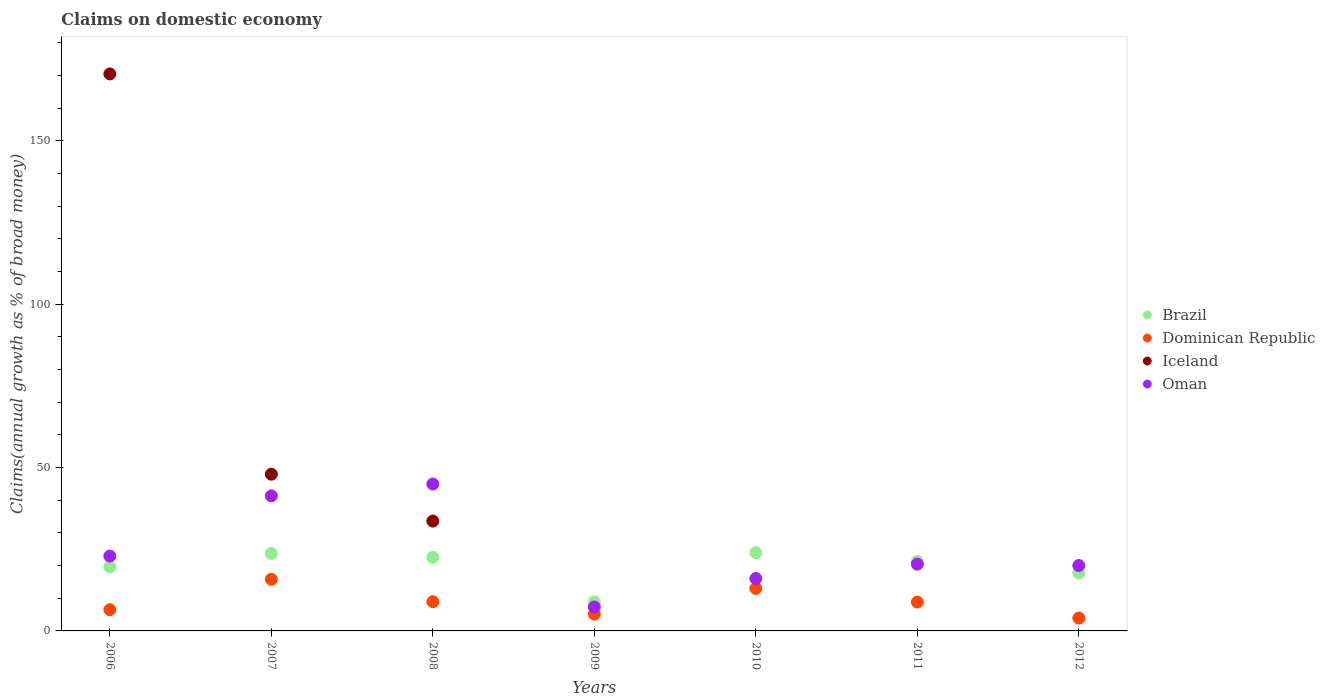What is the percentage of broad money claimed on domestic economy in Brazil in 2006?
Give a very brief answer. 19.61. Across all years, what is the maximum percentage of broad money claimed on domestic economy in Oman?
Your answer should be compact. 44.98. Across all years, what is the minimum percentage of broad money claimed on domestic economy in Oman?
Your answer should be very brief. 7.33. In which year was the percentage of broad money claimed on domestic economy in Dominican Republic maximum?
Offer a very short reply. 2007. What is the total percentage of broad money claimed on domestic economy in Brazil in the graph?
Provide a short and direct response. 137.71. What is the difference between the percentage of broad money claimed on domestic economy in Brazil in 2006 and that in 2008?
Your response must be concise. -2.91. What is the difference between the percentage of broad money claimed on domestic economy in Brazil in 2011 and the percentage of broad money claimed on domestic economy in Iceland in 2009?
Your answer should be very brief. 21.28. What is the average percentage of broad money claimed on domestic economy in Brazil per year?
Keep it short and to the point. 19.67. In the year 2008, what is the difference between the percentage of broad money claimed on domestic economy in Oman and percentage of broad money claimed on domestic economy in Iceland?
Keep it short and to the point. 11.34. What is the ratio of the percentage of broad money claimed on domestic economy in Oman in 2006 to that in 2011?
Your response must be concise. 1.12. Is the percentage of broad money claimed on domestic economy in Oman in 2007 less than that in 2010?
Your answer should be very brief. No. What is the difference between the highest and the second highest percentage of broad money claimed on domestic economy in Iceland?
Your response must be concise. 122.54. What is the difference between the highest and the lowest percentage of broad money claimed on domestic economy in Dominican Republic?
Provide a succinct answer. 11.85. Is the percentage of broad money claimed on domestic economy in Iceland strictly greater than the percentage of broad money claimed on domestic economy in Dominican Republic over the years?
Keep it short and to the point. No. How many dotlines are there?
Offer a terse response. 4. Are the values on the major ticks of Y-axis written in scientific E-notation?
Make the answer very short. No. Does the graph contain any zero values?
Your response must be concise. Yes. Does the graph contain grids?
Ensure brevity in your answer.  No. Where does the legend appear in the graph?
Your answer should be compact. Center right. How many legend labels are there?
Keep it short and to the point. 4. How are the legend labels stacked?
Offer a terse response. Vertical. What is the title of the graph?
Ensure brevity in your answer.  Claims on domestic economy. What is the label or title of the Y-axis?
Your response must be concise. Claims(annual growth as % of broad money). What is the Claims(annual growth as % of broad money) of Brazil in 2006?
Your answer should be compact. 19.61. What is the Claims(annual growth as % of broad money) in Dominican Republic in 2006?
Give a very brief answer. 6.51. What is the Claims(annual growth as % of broad money) of Iceland in 2006?
Offer a very short reply. 170.52. What is the Claims(annual growth as % of broad money) in Oman in 2006?
Ensure brevity in your answer.  22.92. What is the Claims(annual growth as % of broad money) in Brazil in 2007?
Keep it short and to the point. 23.73. What is the Claims(annual growth as % of broad money) in Dominican Republic in 2007?
Offer a terse response. 15.79. What is the Claims(annual growth as % of broad money) in Iceland in 2007?
Your answer should be very brief. 47.98. What is the Claims(annual growth as % of broad money) of Oman in 2007?
Offer a very short reply. 41.35. What is the Claims(annual growth as % of broad money) in Brazil in 2008?
Provide a short and direct response. 22.52. What is the Claims(annual growth as % of broad money) in Dominican Republic in 2008?
Your answer should be very brief. 8.95. What is the Claims(annual growth as % of broad money) in Iceland in 2008?
Ensure brevity in your answer.  33.63. What is the Claims(annual growth as % of broad money) in Oman in 2008?
Provide a short and direct response. 44.98. What is the Claims(annual growth as % of broad money) in Brazil in 2009?
Offer a terse response. 8.89. What is the Claims(annual growth as % of broad money) of Dominican Republic in 2009?
Your answer should be very brief. 5.15. What is the Claims(annual growth as % of broad money) of Iceland in 2009?
Provide a succinct answer. 0. What is the Claims(annual growth as % of broad money) of Oman in 2009?
Offer a terse response. 7.33. What is the Claims(annual growth as % of broad money) in Brazil in 2010?
Your answer should be compact. 23.96. What is the Claims(annual growth as % of broad money) in Dominican Republic in 2010?
Offer a very short reply. 13.01. What is the Claims(annual growth as % of broad money) of Iceland in 2010?
Offer a very short reply. 0. What is the Claims(annual growth as % of broad money) of Oman in 2010?
Ensure brevity in your answer.  16.05. What is the Claims(annual growth as % of broad money) in Brazil in 2011?
Provide a succinct answer. 21.28. What is the Claims(annual growth as % of broad money) of Dominican Republic in 2011?
Your answer should be very brief. 8.83. What is the Claims(annual growth as % of broad money) in Oman in 2011?
Give a very brief answer. 20.43. What is the Claims(annual growth as % of broad money) in Brazil in 2012?
Provide a succinct answer. 17.72. What is the Claims(annual growth as % of broad money) in Dominican Republic in 2012?
Offer a very short reply. 3.94. What is the Claims(annual growth as % of broad money) of Oman in 2012?
Your answer should be compact. 20.01. Across all years, what is the maximum Claims(annual growth as % of broad money) in Brazil?
Ensure brevity in your answer.  23.96. Across all years, what is the maximum Claims(annual growth as % of broad money) in Dominican Republic?
Give a very brief answer. 15.79. Across all years, what is the maximum Claims(annual growth as % of broad money) in Iceland?
Make the answer very short. 170.52. Across all years, what is the maximum Claims(annual growth as % of broad money) in Oman?
Your answer should be very brief. 44.98. Across all years, what is the minimum Claims(annual growth as % of broad money) in Brazil?
Offer a terse response. 8.89. Across all years, what is the minimum Claims(annual growth as % of broad money) in Dominican Republic?
Provide a succinct answer. 3.94. Across all years, what is the minimum Claims(annual growth as % of broad money) in Oman?
Provide a short and direct response. 7.33. What is the total Claims(annual growth as % of broad money) of Brazil in the graph?
Keep it short and to the point. 137.71. What is the total Claims(annual growth as % of broad money) in Dominican Republic in the graph?
Offer a very short reply. 62.18. What is the total Claims(annual growth as % of broad money) in Iceland in the graph?
Offer a very short reply. 252.13. What is the total Claims(annual growth as % of broad money) in Oman in the graph?
Ensure brevity in your answer.  173.06. What is the difference between the Claims(annual growth as % of broad money) in Brazil in 2006 and that in 2007?
Provide a succinct answer. -4.13. What is the difference between the Claims(annual growth as % of broad money) in Dominican Republic in 2006 and that in 2007?
Offer a very short reply. -9.28. What is the difference between the Claims(annual growth as % of broad money) in Iceland in 2006 and that in 2007?
Offer a very short reply. 122.54. What is the difference between the Claims(annual growth as % of broad money) in Oman in 2006 and that in 2007?
Your answer should be very brief. -18.43. What is the difference between the Claims(annual growth as % of broad money) of Brazil in 2006 and that in 2008?
Ensure brevity in your answer.  -2.91. What is the difference between the Claims(annual growth as % of broad money) in Dominican Republic in 2006 and that in 2008?
Keep it short and to the point. -2.44. What is the difference between the Claims(annual growth as % of broad money) in Iceland in 2006 and that in 2008?
Your answer should be very brief. 136.89. What is the difference between the Claims(annual growth as % of broad money) of Oman in 2006 and that in 2008?
Your answer should be compact. -22.06. What is the difference between the Claims(annual growth as % of broad money) of Brazil in 2006 and that in 2009?
Your answer should be very brief. 10.72. What is the difference between the Claims(annual growth as % of broad money) of Dominican Republic in 2006 and that in 2009?
Offer a very short reply. 1.36. What is the difference between the Claims(annual growth as % of broad money) of Oman in 2006 and that in 2009?
Offer a terse response. 15.59. What is the difference between the Claims(annual growth as % of broad money) in Brazil in 2006 and that in 2010?
Your answer should be very brief. -4.35. What is the difference between the Claims(annual growth as % of broad money) in Dominican Republic in 2006 and that in 2010?
Provide a short and direct response. -6.5. What is the difference between the Claims(annual growth as % of broad money) in Oman in 2006 and that in 2010?
Provide a short and direct response. 6.87. What is the difference between the Claims(annual growth as % of broad money) in Brazil in 2006 and that in 2011?
Your answer should be compact. -1.68. What is the difference between the Claims(annual growth as % of broad money) of Dominican Republic in 2006 and that in 2011?
Provide a succinct answer. -2.31. What is the difference between the Claims(annual growth as % of broad money) of Oman in 2006 and that in 2011?
Ensure brevity in your answer.  2.49. What is the difference between the Claims(annual growth as % of broad money) of Brazil in 2006 and that in 2012?
Provide a succinct answer. 1.89. What is the difference between the Claims(annual growth as % of broad money) in Dominican Republic in 2006 and that in 2012?
Make the answer very short. 2.57. What is the difference between the Claims(annual growth as % of broad money) in Oman in 2006 and that in 2012?
Keep it short and to the point. 2.9. What is the difference between the Claims(annual growth as % of broad money) of Brazil in 2007 and that in 2008?
Ensure brevity in your answer.  1.22. What is the difference between the Claims(annual growth as % of broad money) in Dominican Republic in 2007 and that in 2008?
Ensure brevity in your answer.  6.84. What is the difference between the Claims(annual growth as % of broad money) in Iceland in 2007 and that in 2008?
Provide a succinct answer. 14.35. What is the difference between the Claims(annual growth as % of broad money) of Oman in 2007 and that in 2008?
Keep it short and to the point. -3.63. What is the difference between the Claims(annual growth as % of broad money) of Brazil in 2007 and that in 2009?
Offer a very short reply. 14.85. What is the difference between the Claims(annual growth as % of broad money) of Dominican Republic in 2007 and that in 2009?
Provide a short and direct response. 10.64. What is the difference between the Claims(annual growth as % of broad money) of Oman in 2007 and that in 2009?
Provide a succinct answer. 34.02. What is the difference between the Claims(annual growth as % of broad money) of Brazil in 2007 and that in 2010?
Offer a very short reply. -0.23. What is the difference between the Claims(annual growth as % of broad money) in Dominican Republic in 2007 and that in 2010?
Provide a succinct answer. 2.78. What is the difference between the Claims(annual growth as % of broad money) in Oman in 2007 and that in 2010?
Your response must be concise. 25.3. What is the difference between the Claims(annual growth as % of broad money) of Brazil in 2007 and that in 2011?
Keep it short and to the point. 2.45. What is the difference between the Claims(annual growth as % of broad money) in Dominican Republic in 2007 and that in 2011?
Keep it short and to the point. 6.97. What is the difference between the Claims(annual growth as % of broad money) of Oman in 2007 and that in 2011?
Your answer should be compact. 20.92. What is the difference between the Claims(annual growth as % of broad money) in Brazil in 2007 and that in 2012?
Provide a short and direct response. 6.02. What is the difference between the Claims(annual growth as % of broad money) of Dominican Republic in 2007 and that in 2012?
Give a very brief answer. 11.85. What is the difference between the Claims(annual growth as % of broad money) in Oman in 2007 and that in 2012?
Your response must be concise. 21.33. What is the difference between the Claims(annual growth as % of broad money) of Brazil in 2008 and that in 2009?
Your answer should be very brief. 13.63. What is the difference between the Claims(annual growth as % of broad money) of Dominican Republic in 2008 and that in 2009?
Make the answer very short. 3.79. What is the difference between the Claims(annual growth as % of broad money) in Oman in 2008 and that in 2009?
Keep it short and to the point. 37.65. What is the difference between the Claims(annual growth as % of broad money) in Brazil in 2008 and that in 2010?
Offer a terse response. -1.45. What is the difference between the Claims(annual growth as % of broad money) in Dominican Republic in 2008 and that in 2010?
Make the answer very short. -4.06. What is the difference between the Claims(annual growth as % of broad money) of Oman in 2008 and that in 2010?
Offer a very short reply. 28.92. What is the difference between the Claims(annual growth as % of broad money) in Brazil in 2008 and that in 2011?
Offer a very short reply. 1.23. What is the difference between the Claims(annual growth as % of broad money) in Dominican Republic in 2008 and that in 2011?
Offer a very short reply. 0.12. What is the difference between the Claims(annual growth as % of broad money) in Oman in 2008 and that in 2011?
Give a very brief answer. 24.55. What is the difference between the Claims(annual growth as % of broad money) in Brazil in 2008 and that in 2012?
Provide a succinct answer. 4.8. What is the difference between the Claims(annual growth as % of broad money) of Dominican Republic in 2008 and that in 2012?
Give a very brief answer. 5.01. What is the difference between the Claims(annual growth as % of broad money) of Oman in 2008 and that in 2012?
Provide a succinct answer. 24.96. What is the difference between the Claims(annual growth as % of broad money) in Brazil in 2009 and that in 2010?
Offer a very short reply. -15.07. What is the difference between the Claims(annual growth as % of broad money) in Dominican Republic in 2009 and that in 2010?
Offer a very short reply. -7.86. What is the difference between the Claims(annual growth as % of broad money) in Oman in 2009 and that in 2010?
Provide a short and direct response. -8.72. What is the difference between the Claims(annual growth as % of broad money) of Brazil in 2009 and that in 2011?
Make the answer very short. -12.4. What is the difference between the Claims(annual growth as % of broad money) in Dominican Republic in 2009 and that in 2011?
Provide a succinct answer. -3.67. What is the difference between the Claims(annual growth as % of broad money) of Oman in 2009 and that in 2011?
Keep it short and to the point. -13.1. What is the difference between the Claims(annual growth as % of broad money) of Brazil in 2009 and that in 2012?
Your answer should be compact. -8.83. What is the difference between the Claims(annual growth as % of broad money) in Dominican Republic in 2009 and that in 2012?
Make the answer very short. 1.22. What is the difference between the Claims(annual growth as % of broad money) in Oman in 2009 and that in 2012?
Your answer should be very brief. -12.69. What is the difference between the Claims(annual growth as % of broad money) of Brazil in 2010 and that in 2011?
Offer a very short reply. 2.68. What is the difference between the Claims(annual growth as % of broad money) in Dominican Republic in 2010 and that in 2011?
Your response must be concise. 4.19. What is the difference between the Claims(annual growth as % of broad money) in Oman in 2010 and that in 2011?
Make the answer very short. -4.38. What is the difference between the Claims(annual growth as % of broad money) in Brazil in 2010 and that in 2012?
Your response must be concise. 6.24. What is the difference between the Claims(annual growth as % of broad money) of Dominican Republic in 2010 and that in 2012?
Your answer should be compact. 9.07. What is the difference between the Claims(annual growth as % of broad money) of Oman in 2010 and that in 2012?
Offer a very short reply. -3.96. What is the difference between the Claims(annual growth as % of broad money) in Brazil in 2011 and that in 2012?
Offer a terse response. 3.56. What is the difference between the Claims(annual growth as % of broad money) of Dominican Republic in 2011 and that in 2012?
Offer a terse response. 4.89. What is the difference between the Claims(annual growth as % of broad money) of Oman in 2011 and that in 2012?
Your answer should be very brief. 0.41. What is the difference between the Claims(annual growth as % of broad money) in Brazil in 2006 and the Claims(annual growth as % of broad money) in Dominican Republic in 2007?
Provide a succinct answer. 3.82. What is the difference between the Claims(annual growth as % of broad money) in Brazil in 2006 and the Claims(annual growth as % of broad money) in Iceland in 2007?
Provide a short and direct response. -28.37. What is the difference between the Claims(annual growth as % of broad money) of Brazil in 2006 and the Claims(annual growth as % of broad money) of Oman in 2007?
Keep it short and to the point. -21.74. What is the difference between the Claims(annual growth as % of broad money) of Dominican Republic in 2006 and the Claims(annual growth as % of broad money) of Iceland in 2007?
Give a very brief answer. -41.47. What is the difference between the Claims(annual growth as % of broad money) in Dominican Republic in 2006 and the Claims(annual growth as % of broad money) in Oman in 2007?
Offer a terse response. -34.84. What is the difference between the Claims(annual growth as % of broad money) in Iceland in 2006 and the Claims(annual growth as % of broad money) in Oman in 2007?
Your answer should be compact. 129.17. What is the difference between the Claims(annual growth as % of broad money) in Brazil in 2006 and the Claims(annual growth as % of broad money) in Dominican Republic in 2008?
Keep it short and to the point. 10.66. What is the difference between the Claims(annual growth as % of broad money) of Brazil in 2006 and the Claims(annual growth as % of broad money) of Iceland in 2008?
Give a very brief answer. -14.02. What is the difference between the Claims(annual growth as % of broad money) of Brazil in 2006 and the Claims(annual growth as % of broad money) of Oman in 2008?
Your answer should be very brief. -25.37. What is the difference between the Claims(annual growth as % of broad money) in Dominican Republic in 2006 and the Claims(annual growth as % of broad money) in Iceland in 2008?
Provide a short and direct response. -27.12. What is the difference between the Claims(annual growth as % of broad money) of Dominican Republic in 2006 and the Claims(annual growth as % of broad money) of Oman in 2008?
Ensure brevity in your answer.  -38.47. What is the difference between the Claims(annual growth as % of broad money) of Iceland in 2006 and the Claims(annual growth as % of broad money) of Oman in 2008?
Give a very brief answer. 125.54. What is the difference between the Claims(annual growth as % of broad money) of Brazil in 2006 and the Claims(annual growth as % of broad money) of Dominican Republic in 2009?
Offer a very short reply. 14.45. What is the difference between the Claims(annual growth as % of broad money) of Brazil in 2006 and the Claims(annual growth as % of broad money) of Oman in 2009?
Make the answer very short. 12.28. What is the difference between the Claims(annual growth as % of broad money) of Dominican Republic in 2006 and the Claims(annual growth as % of broad money) of Oman in 2009?
Give a very brief answer. -0.82. What is the difference between the Claims(annual growth as % of broad money) of Iceland in 2006 and the Claims(annual growth as % of broad money) of Oman in 2009?
Keep it short and to the point. 163.19. What is the difference between the Claims(annual growth as % of broad money) in Brazil in 2006 and the Claims(annual growth as % of broad money) in Dominican Republic in 2010?
Your answer should be very brief. 6.6. What is the difference between the Claims(annual growth as % of broad money) of Brazil in 2006 and the Claims(annual growth as % of broad money) of Oman in 2010?
Keep it short and to the point. 3.56. What is the difference between the Claims(annual growth as % of broad money) in Dominican Republic in 2006 and the Claims(annual growth as % of broad money) in Oman in 2010?
Your answer should be compact. -9.54. What is the difference between the Claims(annual growth as % of broad money) in Iceland in 2006 and the Claims(annual growth as % of broad money) in Oman in 2010?
Provide a short and direct response. 154.47. What is the difference between the Claims(annual growth as % of broad money) in Brazil in 2006 and the Claims(annual growth as % of broad money) in Dominican Republic in 2011?
Your answer should be very brief. 10.78. What is the difference between the Claims(annual growth as % of broad money) of Brazil in 2006 and the Claims(annual growth as % of broad money) of Oman in 2011?
Offer a terse response. -0.82. What is the difference between the Claims(annual growth as % of broad money) in Dominican Republic in 2006 and the Claims(annual growth as % of broad money) in Oman in 2011?
Ensure brevity in your answer.  -13.92. What is the difference between the Claims(annual growth as % of broad money) of Iceland in 2006 and the Claims(annual growth as % of broad money) of Oman in 2011?
Offer a very short reply. 150.09. What is the difference between the Claims(annual growth as % of broad money) in Brazil in 2006 and the Claims(annual growth as % of broad money) in Dominican Republic in 2012?
Provide a short and direct response. 15.67. What is the difference between the Claims(annual growth as % of broad money) of Brazil in 2006 and the Claims(annual growth as % of broad money) of Oman in 2012?
Make the answer very short. -0.41. What is the difference between the Claims(annual growth as % of broad money) in Dominican Republic in 2006 and the Claims(annual growth as % of broad money) in Oman in 2012?
Make the answer very short. -13.5. What is the difference between the Claims(annual growth as % of broad money) of Iceland in 2006 and the Claims(annual growth as % of broad money) of Oman in 2012?
Ensure brevity in your answer.  150.5. What is the difference between the Claims(annual growth as % of broad money) of Brazil in 2007 and the Claims(annual growth as % of broad money) of Dominican Republic in 2008?
Offer a very short reply. 14.79. What is the difference between the Claims(annual growth as % of broad money) in Brazil in 2007 and the Claims(annual growth as % of broad money) in Iceland in 2008?
Your answer should be very brief. -9.9. What is the difference between the Claims(annual growth as % of broad money) of Brazil in 2007 and the Claims(annual growth as % of broad money) of Oman in 2008?
Provide a succinct answer. -21.24. What is the difference between the Claims(annual growth as % of broad money) of Dominican Republic in 2007 and the Claims(annual growth as % of broad money) of Iceland in 2008?
Provide a succinct answer. -17.84. What is the difference between the Claims(annual growth as % of broad money) in Dominican Republic in 2007 and the Claims(annual growth as % of broad money) in Oman in 2008?
Your answer should be very brief. -29.18. What is the difference between the Claims(annual growth as % of broad money) in Iceland in 2007 and the Claims(annual growth as % of broad money) in Oman in 2008?
Offer a very short reply. 3. What is the difference between the Claims(annual growth as % of broad money) of Brazil in 2007 and the Claims(annual growth as % of broad money) of Dominican Republic in 2009?
Provide a succinct answer. 18.58. What is the difference between the Claims(annual growth as % of broad money) in Brazil in 2007 and the Claims(annual growth as % of broad money) in Oman in 2009?
Offer a very short reply. 16.41. What is the difference between the Claims(annual growth as % of broad money) in Dominican Republic in 2007 and the Claims(annual growth as % of broad money) in Oman in 2009?
Your answer should be compact. 8.47. What is the difference between the Claims(annual growth as % of broad money) of Iceland in 2007 and the Claims(annual growth as % of broad money) of Oman in 2009?
Give a very brief answer. 40.65. What is the difference between the Claims(annual growth as % of broad money) of Brazil in 2007 and the Claims(annual growth as % of broad money) of Dominican Republic in 2010?
Provide a succinct answer. 10.72. What is the difference between the Claims(annual growth as % of broad money) of Brazil in 2007 and the Claims(annual growth as % of broad money) of Oman in 2010?
Your answer should be very brief. 7.68. What is the difference between the Claims(annual growth as % of broad money) in Dominican Republic in 2007 and the Claims(annual growth as % of broad money) in Oman in 2010?
Offer a terse response. -0.26. What is the difference between the Claims(annual growth as % of broad money) in Iceland in 2007 and the Claims(annual growth as % of broad money) in Oman in 2010?
Offer a very short reply. 31.93. What is the difference between the Claims(annual growth as % of broad money) in Brazil in 2007 and the Claims(annual growth as % of broad money) in Dominican Republic in 2011?
Provide a succinct answer. 14.91. What is the difference between the Claims(annual growth as % of broad money) of Brazil in 2007 and the Claims(annual growth as % of broad money) of Oman in 2011?
Provide a succinct answer. 3.31. What is the difference between the Claims(annual growth as % of broad money) of Dominican Republic in 2007 and the Claims(annual growth as % of broad money) of Oman in 2011?
Provide a succinct answer. -4.64. What is the difference between the Claims(annual growth as % of broad money) in Iceland in 2007 and the Claims(annual growth as % of broad money) in Oman in 2011?
Make the answer very short. 27.55. What is the difference between the Claims(annual growth as % of broad money) of Brazil in 2007 and the Claims(annual growth as % of broad money) of Dominican Republic in 2012?
Ensure brevity in your answer.  19.8. What is the difference between the Claims(annual growth as % of broad money) of Brazil in 2007 and the Claims(annual growth as % of broad money) of Oman in 2012?
Offer a very short reply. 3.72. What is the difference between the Claims(annual growth as % of broad money) in Dominican Republic in 2007 and the Claims(annual growth as % of broad money) in Oman in 2012?
Give a very brief answer. -4.22. What is the difference between the Claims(annual growth as % of broad money) of Iceland in 2007 and the Claims(annual growth as % of broad money) of Oman in 2012?
Give a very brief answer. 27.97. What is the difference between the Claims(annual growth as % of broad money) of Brazil in 2008 and the Claims(annual growth as % of broad money) of Dominican Republic in 2009?
Offer a very short reply. 17.36. What is the difference between the Claims(annual growth as % of broad money) of Brazil in 2008 and the Claims(annual growth as % of broad money) of Oman in 2009?
Offer a terse response. 15.19. What is the difference between the Claims(annual growth as % of broad money) in Dominican Republic in 2008 and the Claims(annual growth as % of broad money) in Oman in 2009?
Your response must be concise. 1.62. What is the difference between the Claims(annual growth as % of broad money) of Iceland in 2008 and the Claims(annual growth as % of broad money) of Oman in 2009?
Ensure brevity in your answer.  26.31. What is the difference between the Claims(annual growth as % of broad money) of Brazil in 2008 and the Claims(annual growth as % of broad money) of Dominican Republic in 2010?
Provide a succinct answer. 9.51. What is the difference between the Claims(annual growth as % of broad money) of Brazil in 2008 and the Claims(annual growth as % of broad money) of Oman in 2010?
Ensure brevity in your answer.  6.46. What is the difference between the Claims(annual growth as % of broad money) of Dominican Republic in 2008 and the Claims(annual growth as % of broad money) of Oman in 2010?
Offer a very short reply. -7.1. What is the difference between the Claims(annual growth as % of broad money) of Iceland in 2008 and the Claims(annual growth as % of broad money) of Oman in 2010?
Give a very brief answer. 17.58. What is the difference between the Claims(annual growth as % of broad money) in Brazil in 2008 and the Claims(annual growth as % of broad money) in Dominican Republic in 2011?
Make the answer very short. 13.69. What is the difference between the Claims(annual growth as % of broad money) of Brazil in 2008 and the Claims(annual growth as % of broad money) of Oman in 2011?
Your answer should be compact. 2.09. What is the difference between the Claims(annual growth as % of broad money) in Dominican Republic in 2008 and the Claims(annual growth as % of broad money) in Oman in 2011?
Give a very brief answer. -11.48. What is the difference between the Claims(annual growth as % of broad money) of Iceland in 2008 and the Claims(annual growth as % of broad money) of Oman in 2011?
Provide a short and direct response. 13.2. What is the difference between the Claims(annual growth as % of broad money) of Brazil in 2008 and the Claims(annual growth as % of broad money) of Dominican Republic in 2012?
Your answer should be compact. 18.58. What is the difference between the Claims(annual growth as % of broad money) in Brazil in 2008 and the Claims(annual growth as % of broad money) in Oman in 2012?
Your answer should be compact. 2.5. What is the difference between the Claims(annual growth as % of broad money) of Dominican Republic in 2008 and the Claims(annual growth as % of broad money) of Oman in 2012?
Provide a short and direct response. -11.07. What is the difference between the Claims(annual growth as % of broad money) of Iceland in 2008 and the Claims(annual growth as % of broad money) of Oman in 2012?
Keep it short and to the point. 13.62. What is the difference between the Claims(annual growth as % of broad money) in Brazil in 2009 and the Claims(annual growth as % of broad money) in Dominican Republic in 2010?
Offer a very short reply. -4.12. What is the difference between the Claims(annual growth as % of broad money) in Brazil in 2009 and the Claims(annual growth as % of broad money) in Oman in 2010?
Ensure brevity in your answer.  -7.16. What is the difference between the Claims(annual growth as % of broad money) of Dominican Republic in 2009 and the Claims(annual growth as % of broad money) of Oman in 2010?
Keep it short and to the point. -10.9. What is the difference between the Claims(annual growth as % of broad money) in Brazil in 2009 and the Claims(annual growth as % of broad money) in Dominican Republic in 2011?
Offer a very short reply. 0.06. What is the difference between the Claims(annual growth as % of broad money) of Brazil in 2009 and the Claims(annual growth as % of broad money) of Oman in 2011?
Offer a very short reply. -11.54. What is the difference between the Claims(annual growth as % of broad money) of Dominican Republic in 2009 and the Claims(annual growth as % of broad money) of Oman in 2011?
Offer a terse response. -15.27. What is the difference between the Claims(annual growth as % of broad money) in Brazil in 2009 and the Claims(annual growth as % of broad money) in Dominican Republic in 2012?
Keep it short and to the point. 4.95. What is the difference between the Claims(annual growth as % of broad money) of Brazil in 2009 and the Claims(annual growth as % of broad money) of Oman in 2012?
Offer a very short reply. -11.13. What is the difference between the Claims(annual growth as % of broad money) in Dominican Republic in 2009 and the Claims(annual growth as % of broad money) in Oman in 2012?
Your answer should be very brief. -14.86. What is the difference between the Claims(annual growth as % of broad money) of Brazil in 2010 and the Claims(annual growth as % of broad money) of Dominican Republic in 2011?
Make the answer very short. 15.14. What is the difference between the Claims(annual growth as % of broad money) in Brazil in 2010 and the Claims(annual growth as % of broad money) in Oman in 2011?
Your answer should be very brief. 3.53. What is the difference between the Claims(annual growth as % of broad money) of Dominican Republic in 2010 and the Claims(annual growth as % of broad money) of Oman in 2011?
Provide a succinct answer. -7.42. What is the difference between the Claims(annual growth as % of broad money) of Brazil in 2010 and the Claims(annual growth as % of broad money) of Dominican Republic in 2012?
Keep it short and to the point. 20.02. What is the difference between the Claims(annual growth as % of broad money) in Brazil in 2010 and the Claims(annual growth as % of broad money) in Oman in 2012?
Provide a succinct answer. 3.95. What is the difference between the Claims(annual growth as % of broad money) of Dominican Republic in 2010 and the Claims(annual growth as % of broad money) of Oman in 2012?
Provide a succinct answer. -7. What is the difference between the Claims(annual growth as % of broad money) of Brazil in 2011 and the Claims(annual growth as % of broad money) of Dominican Republic in 2012?
Offer a terse response. 17.35. What is the difference between the Claims(annual growth as % of broad money) in Brazil in 2011 and the Claims(annual growth as % of broad money) in Oman in 2012?
Your response must be concise. 1.27. What is the difference between the Claims(annual growth as % of broad money) of Dominican Republic in 2011 and the Claims(annual growth as % of broad money) of Oman in 2012?
Make the answer very short. -11.19. What is the average Claims(annual growth as % of broad money) in Brazil per year?
Your answer should be very brief. 19.67. What is the average Claims(annual growth as % of broad money) of Dominican Republic per year?
Offer a very short reply. 8.88. What is the average Claims(annual growth as % of broad money) in Iceland per year?
Make the answer very short. 36.02. What is the average Claims(annual growth as % of broad money) in Oman per year?
Make the answer very short. 24.72. In the year 2006, what is the difference between the Claims(annual growth as % of broad money) in Brazil and Claims(annual growth as % of broad money) in Dominican Republic?
Provide a short and direct response. 13.1. In the year 2006, what is the difference between the Claims(annual growth as % of broad money) in Brazil and Claims(annual growth as % of broad money) in Iceland?
Your answer should be compact. -150.91. In the year 2006, what is the difference between the Claims(annual growth as % of broad money) in Brazil and Claims(annual growth as % of broad money) in Oman?
Your answer should be very brief. -3.31. In the year 2006, what is the difference between the Claims(annual growth as % of broad money) of Dominican Republic and Claims(annual growth as % of broad money) of Iceland?
Offer a very short reply. -164.01. In the year 2006, what is the difference between the Claims(annual growth as % of broad money) of Dominican Republic and Claims(annual growth as % of broad money) of Oman?
Offer a very short reply. -16.41. In the year 2006, what is the difference between the Claims(annual growth as % of broad money) of Iceland and Claims(annual growth as % of broad money) of Oman?
Provide a short and direct response. 147.6. In the year 2007, what is the difference between the Claims(annual growth as % of broad money) of Brazil and Claims(annual growth as % of broad money) of Dominican Republic?
Your answer should be very brief. 7.94. In the year 2007, what is the difference between the Claims(annual growth as % of broad money) in Brazil and Claims(annual growth as % of broad money) in Iceland?
Make the answer very short. -24.25. In the year 2007, what is the difference between the Claims(annual growth as % of broad money) in Brazil and Claims(annual growth as % of broad money) in Oman?
Provide a short and direct response. -17.61. In the year 2007, what is the difference between the Claims(annual growth as % of broad money) in Dominican Republic and Claims(annual growth as % of broad money) in Iceland?
Give a very brief answer. -32.19. In the year 2007, what is the difference between the Claims(annual growth as % of broad money) of Dominican Republic and Claims(annual growth as % of broad money) of Oman?
Provide a short and direct response. -25.56. In the year 2007, what is the difference between the Claims(annual growth as % of broad money) of Iceland and Claims(annual growth as % of broad money) of Oman?
Provide a succinct answer. 6.63. In the year 2008, what is the difference between the Claims(annual growth as % of broad money) in Brazil and Claims(annual growth as % of broad money) in Dominican Republic?
Give a very brief answer. 13.57. In the year 2008, what is the difference between the Claims(annual growth as % of broad money) in Brazil and Claims(annual growth as % of broad money) in Iceland?
Offer a terse response. -11.12. In the year 2008, what is the difference between the Claims(annual growth as % of broad money) in Brazil and Claims(annual growth as % of broad money) in Oman?
Make the answer very short. -22.46. In the year 2008, what is the difference between the Claims(annual growth as % of broad money) of Dominican Republic and Claims(annual growth as % of broad money) of Iceland?
Your answer should be compact. -24.69. In the year 2008, what is the difference between the Claims(annual growth as % of broad money) of Dominican Republic and Claims(annual growth as % of broad money) of Oman?
Provide a short and direct response. -36.03. In the year 2008, what is the difference between the Claims(annual growth as % of broad money) in Iceland and Claims(annual growth as % of broad money) in Oman?
Offer a very short reply. -11.34. In the year 2009, what is the difference between the Claims(annual growth as % of broad money) of Brazil and Claims(annual growth as % of broad money) of Dominican Republic?
Keep it short and to the point. 3.73. In the year 2009, what is the difference between the Claims(annual growth as % of broad money) of Brazil and Claims(annual growth as % of broad money) of Oman?
Offer a terse response. 1.56. In the year 2009, what is the difference between the Claims(annual growth as % of broad money) in Dominican Republic and Claims(annual growth as % of broad money) in Oman?
Your answer should be very brief. -2.17. In the year 2010, what is the difference between the Claims(annual growth as % of broad money) of Brazil and Claims(annual growth as % of broad money) of Dominican Republic?
Keep it short and to the point. 10.95. In the year 2010, what is the difference between the Claims(annual growth as % of broad money) of Brazil and Claims(annual growth as % of broad money) of Oman?
Keep it short and to the point. 7.91. In the year 2010, what is the difference between the Claims(annual growth as % of broad money) in Dominican Republic and Claims(annual growth as % of broad money) in Oman?
Provide a succinct answer. -3.04. In the year 2011, what is the difference between the Claims(annual growth as % of broad money) of Brazil and Claims(annual growth as % of broad money) of Dominican Republic?
Give a very brief answer. 12.46. In the year 2011, what is the difference between the Claims(annual growth as % of broad money) in Brazil and Claims(annual growth as % of broad money) in Oman?
Your answer should be very brief. 0.86. In the year 2011, what is the difference between the Claims(annual growth as % of broad money) of Dominican Republic and Claims(annual growth as % of broad money) of Oman?
Your response must be concise. -11.6. In the year 2012, what is the difference between the Claims(annual growth as % of broad money) of Brazil and Claims(annual growth as % of broad money) of Dominican Republic?
Your answer should be very brief. 13.78. In the year 2012, what is the difference between the Claims(annual growth as % of broad money) in Brazil and Claims(annual growth as % of broad money) in Oman?
Give a very brief answer. -2.3. In the year 2012, what is the difference between the Claims(annual growth as % of broad money) of Dominican Republic and Claims(annual growth as % of broad money) of Oman?
Make the answer very short. -16.08. What is the ratio of the Claims(annual growth as % of broad money) of Brazil in 2006 to that in 2007?
Make the answer very short. 0.83. What is the ratio of the Claims(annual growth as % of broad money) of Dominican Republic in 2006 to that in 2007?
Ensure brevity in your answer.  0.41. What is the ratio of the Claims(annual growth as % of broad money) of Iceland in 2006 to that in 2007?
Make the answer very short. 3.55. What is the ratio of the Claims(annual growth as % of broad money) of Oman in 2006 to that in 2007?
Ensure brevity in your answer.  0.55. What is the ratio of the Claims(annual growth as % of broad money) of Brazil in 2006 to that in 2008?
Your response must be concise. 0.87. What is the ratio of the Claims(annual growth as % of broad money) of Dominican Republic in 2006 to that in 2008?
Provide a succinct answer. 0.73. What is the ratio of the Claims(annual growth as % of broad money) in Iceland in 2006 to that in 2008?
Offer a terse response. 5.07. What is the ratio of the Claims(annual growth as % of broad money) in Oman in 2006 to that in 2008?
Give a very brief answer. 0.51. What is the ratio of the Claims(annual growth as % of broad money) in Brazil in 2006 to that in 2009?
Give a very brief answer. 2.21. What is the ratio of the Claims(annual growth as % of broad money) of Dominican Republic in 2006 to that in 2009?
Ensure brevity in your answer.  1.26. What is the ratio of the Claims(annual growth as % of broad money) in Oman in 2006 to that in 2009?
Your answer should be compact. 3.13. What is the ratio of the Claims(annual growth as % of broad money) of Brazil in 2006 to that in 2010?
Provide a short and direct response. 0.82. What is the ratio of the Claims(annual growth as % of broad money) of Dominican Republic in 2006 to that in 2010?
Your response must be concise. 0.5. What is the ratio of the Claims(annual growth as % of broad money) of Oman in 2006 to that in 2010?
Your answer should be very brief. 1.43. What is the ratio of the Claims(annual growth as % of broad money) of Brazil in 2006 to that in 2011?
Provide a succinct answer. 0.92. What is the ratio of the Claims(annual growth as % of broad money) in Dominican Republic in 2006 to that in 2011?
Your answer should be very brief. 0.74. What is the ratio of the Claims(annual growth as % of broad money) of Oman in 2006 to that in 2011?
Provide a short and direct response. 1.12. What is the ratio of the Claims(annual growth as % of broad money) in Brazil in 2006 to that in 2012?
Your answer should be very brief. 1.11. What is the ratio of the Claims(annual growth as % of broad money) in Dominican Republic in 2006 to that in 2012?
Offer a very short reply. 1.65. What is the ratio of the Claims(annual growth as % of broad money) in Oman in 2006 to that in 2012?
Give a very brief answer. 1.15. What is the ratio of the Claims(annual growth as % of broad money) in Brazil in 2007 to that in 2008?
Offer a terse response. 1.05. What is the ratio of the Claims(annual growth as % of broad money) in Dominican Republic in 2007 to that in 2008?
Your answer should be compact. 1.76. What is the ratio of the Claims(annual growth as % of broad money) of Iceland in 2007 to that in 2008?
Ensure brevity in your answer.  1.43. What is the ratio of the Claims(annual growth as % of broad money) of Oman in 2007 to that in 2008?
Your response must be concise. 0.92. What is the ratio of the Claims(annual growth as % of broad money) of Brazil in 2007 to that in 2009?
Provide a short and direct response. 2.67. What is the ratio of the Claims(annual growth as % of broad money) of Dominican Republic in 2007 to that in 2009?
Ensure brevity in your answer.  3.06. What is the ratio of the Claims(annual growth as % of broad money) of Oman in 2007 to that in 2009?
Make the answer very short. 5.64. What is the ratio of the Claims(annual growth as % of broad money) in Dominican Republic in 2007 to that in 2010?
Make the answer very short. 1.21. What is the ratio of the Claims(annual growth as % of broad money) in Oman in 2007 to that in 2010?
Your answer should be compact. 2.58. What is the ratio of the Claims(annual growth as % of broad money) in Brazil in 2007 to that in 2011?
Your answer should be compact. 1.12. What is the ratio of the Claims(annual growth as % of broad money) of Dominican Republic in 2007 to that in 2011?
Ensure brevity in your answer.  1.79. What is the ratio of the Claims(annual growth as % of broad money) of Oman in 2007 to that in 2011?
Ensure brevity in your answer.  2.02. What is the ratio of the Claims(annual growth as % of broad money) of Brazil in 2007 to that in 2012?
Give a very brief answer. 1.34. What is the ratio of the Claims(annual growth as % of broad money) of Dominican Republic in 2007 to that in 2012?
Ensure brevity in your answer.  4.01. What is the ratio of the Claims(annual growth as % of broad money) in Oman in 2007 to that in 2012?
Make the answer very short. 2.07. What is the ratio of the Claims(annual growth as % of broad money) of Brazil in 2008 to that in 2009?
Ensure brevity in your answer.  2.53. What is the ratio of the Claims(annual growth as % of broad money) of Dominican Republic in 2008 to that in 2009?
Provide a succinct answer. 1.74. What is the ratio of the Claims(annual growth as % of broad money) of Oman in 2008 to that in 2009?
Offer a terse response. 6.14. What is the ratio of the Claims(annual growth as % of broad money) of Brazil in 2008 to that in 2010?
Give a very brief answer. 0.94. What is the ratio of the Claims(annual growth as % of broad money) of Dominican Republic in 2008 to that in 2010?
Provide a short and direct response. 0.69. What is the ratio of the Claims(annual growth as % of broad money) of Oman in 2008 to that in 2010?
Give a very brief answer. 2.8. What is the ratio of the Claims(annual growth as % of broad money) in Brazil in 2008 to that in 2011?
Provide a succinct answer. 1.06. What is the ratio of the Claims(annual growth as % of broad money) of Dominican Republic in 2008 to that in 2011?
Your answer should be compact. 1.01. What is the ratio of the Claims(annual growth as % of broad money) of Oman in 2008 to that in 2011?
Keep it short and to the point. 2.2. What is the ratio of the Claims(annual growth as % of broad money) in Brazil in 2008 to that in 2012?
Your answer should be compact. 1.27. What is the ratio of the Claims(annual growth as % of broad money) in Dominican Republic in 2008 to that in 2012?
Make the answer very short. 2.27. What is the ratio of the Claims(annual growth as % of broad money) of Oman in 2008 to that in 2012?
Make the answer very short. 2.25. What is the ratio of the Claims(annual growth as % of broad money) in Brazil in 2009 to that in 2010?
Offer a terse response. 0.37. What is the ratio of the Claims(annual growth as % of broad money) in Dominican Republic in 2009 to that in 2010?
Your response must be concise. 0.4. What is the ratio of the Claims(annual growth as % of broad money) in Oman in 2009 to that in 2010?
Offer a terse response. 0.46. What is the ratio of the Claims(annual growth as % of broad money) of Brazil in 2009 to that in 2011?
Your answer should be compact. 0.42. What is the ratio of the Claims(annual growth as % of broad money) in Dominican Republic in 2009 to that in 2011?
Keep it short and to the point. 0.58. What is the ratio of the Claims(annual growth as % of broad money) in Oman in 2009 to that in 2011?
Offer a very short reply. 0.36. What is the ratio of the Claims(annual growth as % of broad money) of Brazil in 2009 to that in 2012?
Keep it short and to the point. 0.5. What is the ratio of the Claims(annual growth as % of broad money) in Dominican Republic in 2009 to that in 2012?
Offer a very short reply. 1.31. What is the ratio of the Claims(annual growth as % of broad money) in Oman in 2009 to that in 2012?
Ensure brevity in your answer.  0.37. What is the ratio of the Claims(annual growth as % of broad money) in Brazil in 2010 to that in 2011?
Your response must be concise. 1.13. What is the ratio of the Claims(annual growth as % of broad money) in Dominican Republic in 2010 to that in 2011?
Keep it short and to the point. 1.47. What is the ratio of the Claims(annual growth as % of broad money) in Oman in 2010 to that in 2011?
Give a very brief answer. 0.79. What is the ratio of the Claims(annual growth as % of broad money) in Brazil in 2010 to that in 2012?
Make the answer very short. 1.35. What is the ratio of the Claims(annual growth as % of broad money) in Dominican Republic in 2010 to that in 2012?
Ensure brevity in your answer.  3.3. What is the ratio of the Claims(annual growth as % of broad money) in Oman in 2010 to that in 2012?
Give a very brief answer. 0.8. What is the ratio of the Claims(annual growth as % of broad money) of Brazil in 2011 to that in 2012?
Make the answer very short. 1.2. What is the ratio of the Claims(annual growth as % of broad money) in Dominican Republic in 2011 to that in 2012?
Offer a very short reply. 2.24. What is the ratio of the Claims(annual growth as % of broad money) in Oman in 2011 to that in 2012?
Keep it short and to the point. 1.02. What is the difference between the highest and the second highest Claims(annual growth as % of broad money) of Brazil?
Make the answer very short. 0.23. What is the difference between the highest and the second highest Claims(annual growth as % of broad money) in Dominican Republic?
Make the answer very short. 2.78. What is the difference between the highest and the second highest Claims(annual growth as % of broad money) of Iceland?
Your response must be concise. 122.54. What is the difference between the highest and the second highest Claims(annual growth as % of broad money) of Oman?
Provide a short and direct response. 3.63. What is the difference between the highest and the lowest Claims(annual growth as % of broad money) in Brazil?
Your answer should be very brief. 15.07. What is the difference between the highest and the lowest Claims(annual growth as % of broad money) in Dominican Republic?
Your response must be concise. 11.85. What is the difference between the highest and the lowest Claims(annual growth as % of broad money) in Iceland?
Provide a succinct answer. 170.52. What is the difference between the highest and the lowest Claims(annual growth as % of broad money) in Oman?
Provide a succinct answer. 37.65. 